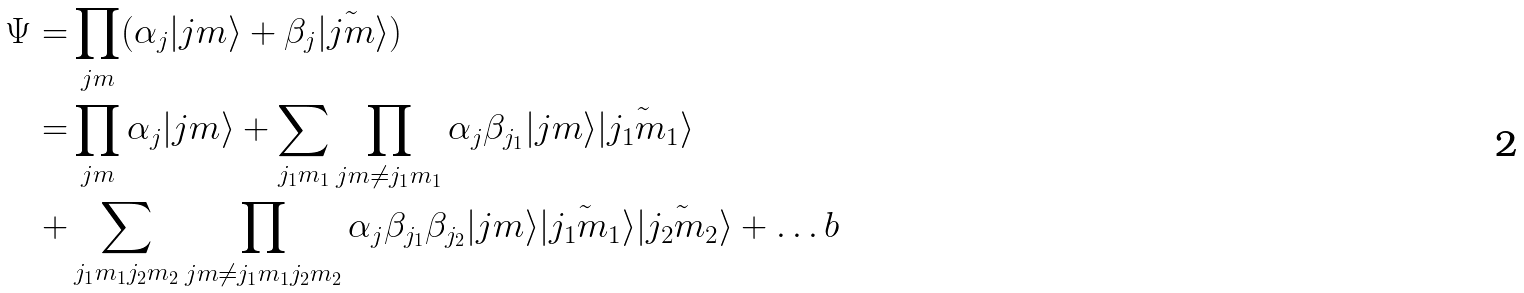Convert formula to latex. <formula><loc_0><loc_0><loc_500><loc_500>\Psi = & \prod _ { j m } ( \alpha _ { j } | { j m } \rangle + \beta _ { j } | \tilde { j m } \rangle ) \\ = & \prod _ { j m } \alpha _ { j } | { j m } \rangle + \sum _ { j _ { 1 } m _ { 1 } } \prod _ { { j m } \neq j _ { 1 } m _ { 1 } } \alpha _ { j } \beta _ { j _ { 1 } } | { j m } \rangle | \tilde { j _ { 1 } m _ { 1 } } \rangle \\ + & \sum _ { j _ { 1 } m _ { 1 } j _ { 2 } m _ { 2 } } \prod _ { { j m } \neq j _ { 1 } m _ { 1 } j _ { 2 } m _ { 2 } } \alpha _ { j } \beta _ { j _ { 1 } } \beta _ { j _ { 2 } } | { j m } \rangle | \tilde { j _ { 1 } m _ { 1 } } \rangle | \tilde { j _ { 2 } m _ { 2 } } \rangle + \dots b</formula> 